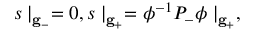<formula> <loc_0><loc_0><loc_500><loc_500>s | _ { { g } _ { - } } = 0 , s | _ { { g } _ { + } } = \phi ^ { - 1 } P _ { - } \phi | _ { { g } _ { + } } ,</formula> 